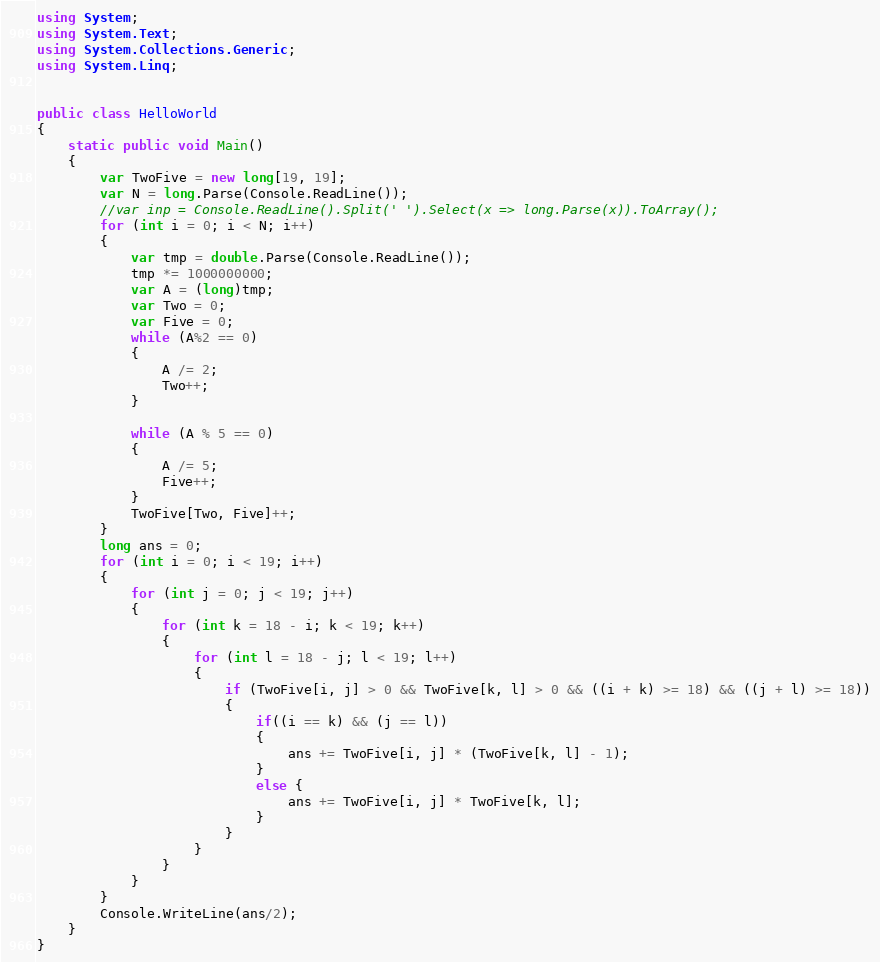Convert code to text. <code><loc_0><loc_0><loc_500><loc_500><_C#_>using System;
using System.Text;
using System.Collections.Generic;
using System.Linq;


public class HelloWorld
{
    static public void Main()
    {
        var TwoFive = new long[19, 19];
        var N = long.Parse(Console.ReadLine());
        //var inp = Console.ReadLine().Split(' ').Select(x => long.Parse(x)).ToArray();
        for (int i = 0; i < N; i++)
        {
            var tmp = double.Parse(Console.ReadLine());
            tmp *= 1000000000;
            var A = (long)tmp;
            var Two = 0;
            var Five = 0;
            while (A%2 == 0)
            {
                A /= 2;
                Two++;
            }

            while (A % 5 == 0)
            {
                A /= 5;
                Five++;
            }
            TwoFive[Two, Five]++;
        }
        long ans = 0;
        for (int i = 0; i < 19; i++)
        {
            for (int j = 0; j < 19; j++)
            {
                for (int k = 18 - i; k < 19; k++)
                {
                    for (int l = 18 - j; l < 19; l++)
                    {
                        if (TwoFive[i, j] > 0 && TwoFive[k, l] > 0 && ((i + k) >= 18) && ((j + l) >= 18))
                        {
                            if((i == k) && (j == l))
                            {
                                ans += TwoFive[i, j] * (TwoFive[k, l] - 1);
                            }
                            else {
                                ans += TwoFive[i, j] * TwoFive[k, l];
                            }
                        }
                    }
                }
            }
        }
        Console.WriteLine(ans/2);
    }
}</code> 